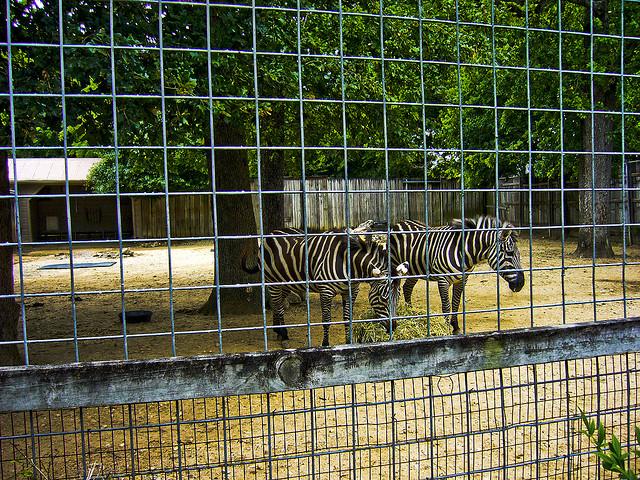Is the zebra on right hungry?
Write a very short answer. No. Is It a sunny or cloudy day?
Answer briefly. Sunny. What are the animals?
Concise answer only. Zebras. 